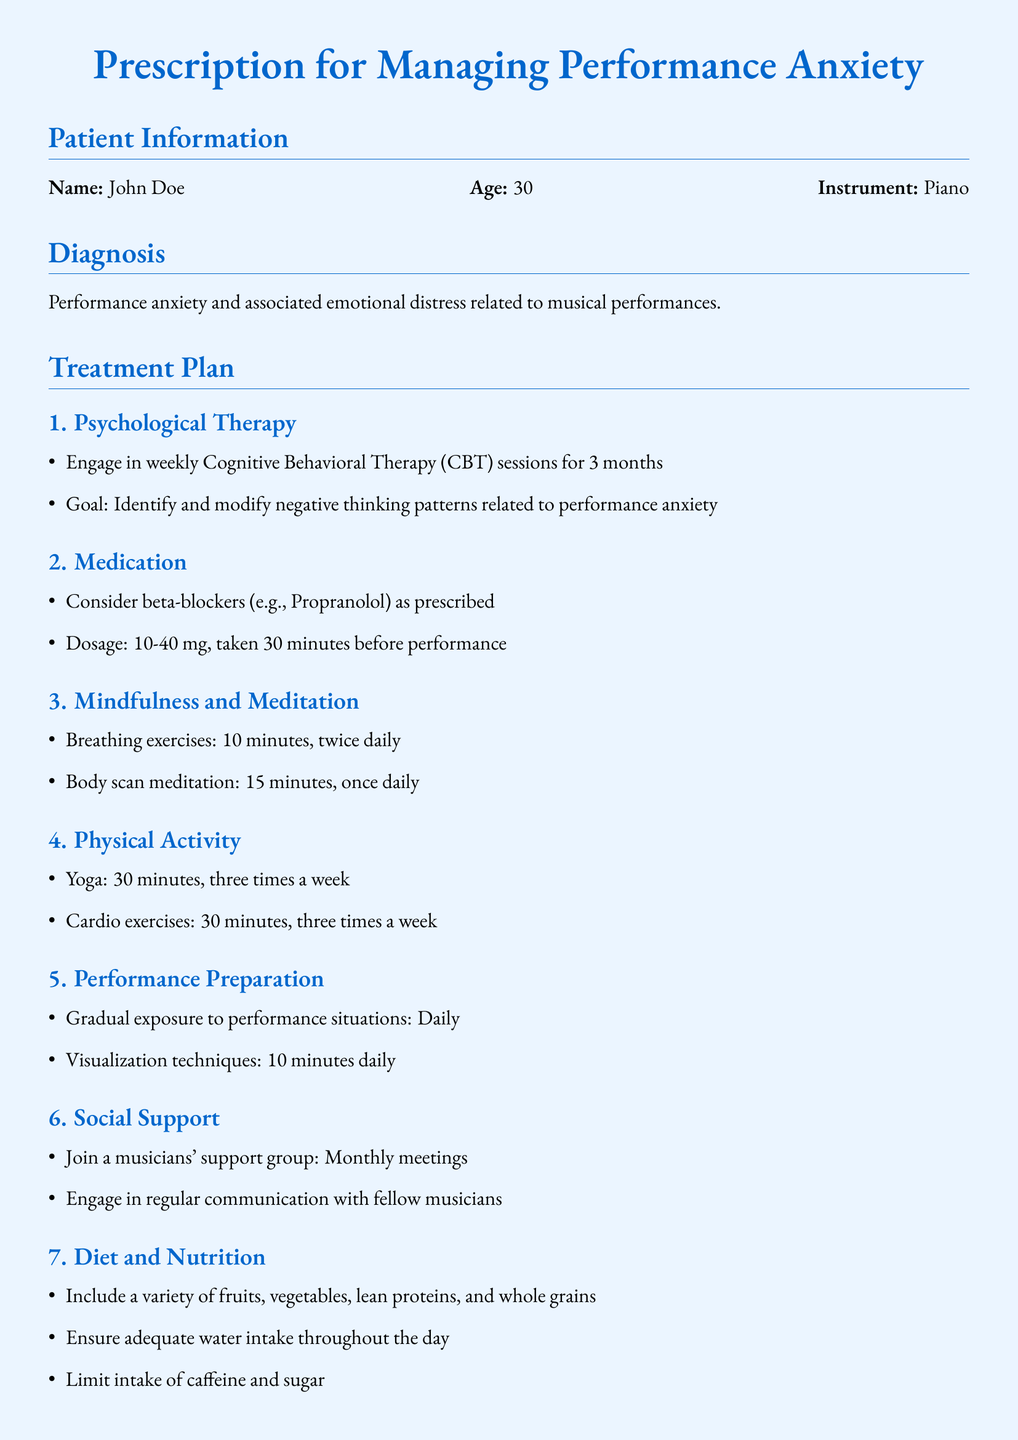What is the patient's name? The patient's name is stated in the Patient Information section of the document.
Answer: John Doe What age is the patient? The age of the patient is listed in the Patient Information section.
Answer: 30 What type of therapy is recommended? The type of therapy mentioned in the Treatment Plan is found in the Psychological Therapy subsection.
Answer: Cognitive Behavioral Therapy (CBT) How long should the patient engage in psychological therapy? The duration for the therapy is specified in the Psychological Therapy subsection.
Answer: 3 months What medication is recommended for performance anxiety? The medication suggested in the Treatment Plan is located in the Medication subsection.
Answer: beta-blockers What physical activity is suggested three times a week? The specific physical activity mentioned in the Physical Activity subsection needs to be found.
Answer: Yoga What is the dosage range for the medication? The dosage range for the medication is provided in the Medication subsection.
Answer: 10-40 mg How often should the patient perform breathing exercises? The frequency of the breathing exercises is detailed in the Mindfulness and Meditation subsection.
Answer: twice daily What is one goal for the psychological therapy? One of the goals for therapy can be identified in the Psychological Therapy subsection.
Answer: Identify and modify negative thinking patterns How often should the patient join a musicians' support group? The frequency of the support group meetings is stated in the Social Support subsection.
Answer: Monthly meetings 